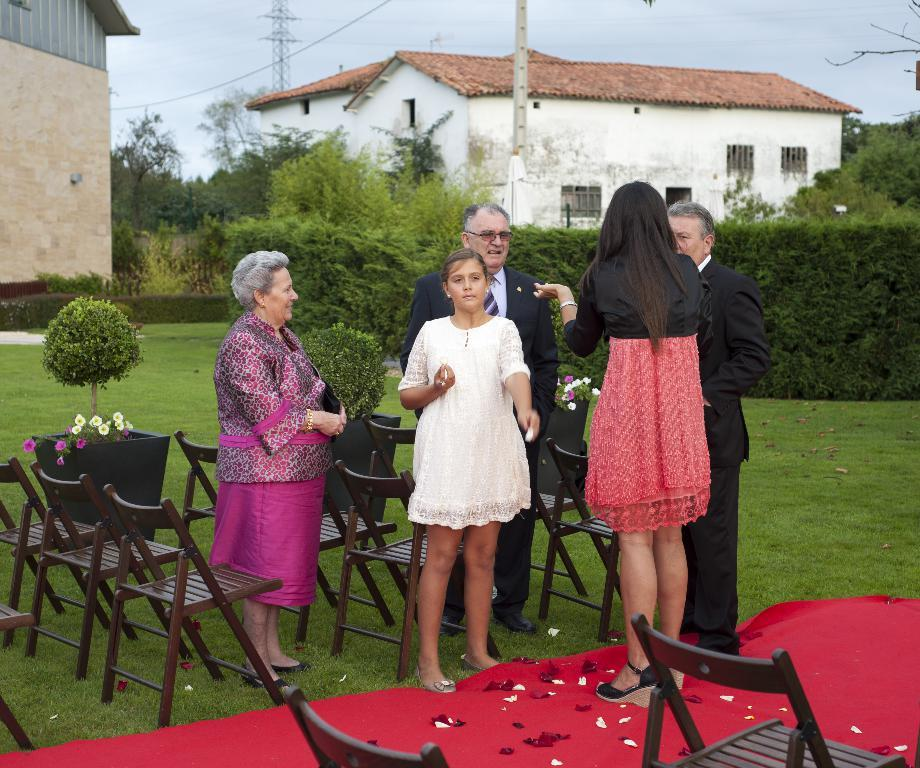What is the main subject in the center of the image? There are people in the center of the image. What else can be seen in the image besides the people? There are cars and houses in the image. What type of vegetation is visible at the top side of the image? There are trees at the top side of the image. Where is the turkey located in the image? There is no turkey present in the image. What type of thrill can be experienced by the people in the image? The image does not provide information about any specific thrill experienced by the people. 